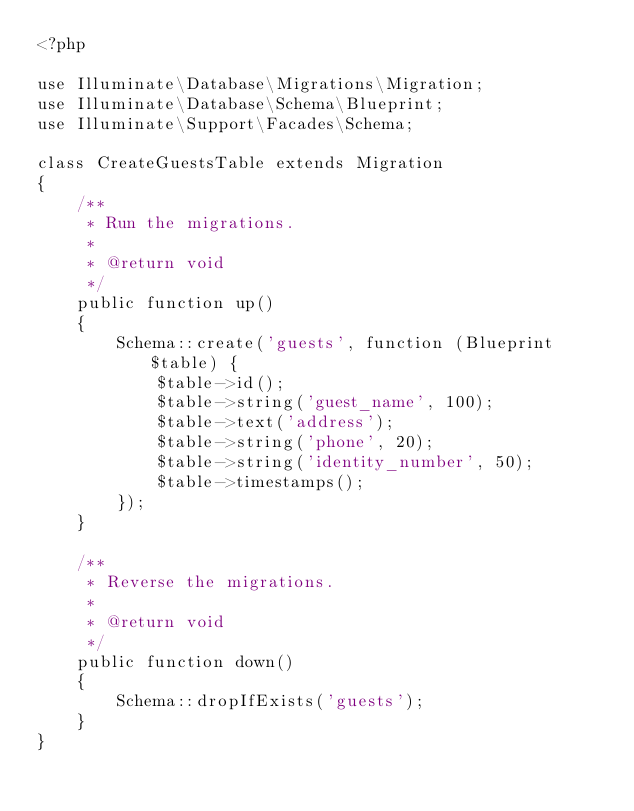Convert code to text. <code><loc_0><loc_0><loc_500><loc_500><_PHP_><?php

use Illuminate\Database\Migrations\Migration;
use Illuminate\Database\Schema\Blueprint;
use Illuminate\Support\Facades\Schema;

class CreateGuestsTable extends Migration
{
    /**
     * Run the migrations.
     *
     * @return void
     */
    public function up()
    {
        Schema::create('guests', function (Blueprint $table) {
            $table->id();
            $table->string('guest_name', 100);
            $table->text('address');
            $table->string('phone', 20);
            $table->string('identity_number', 50);
            $table->timestamps();
        });
    }

    /**
     * Reverse the migrations.
     *
     * @return void
     */
    public function down()
    {
        Schema::dropIfExists('guests');
    }
}
</code> 